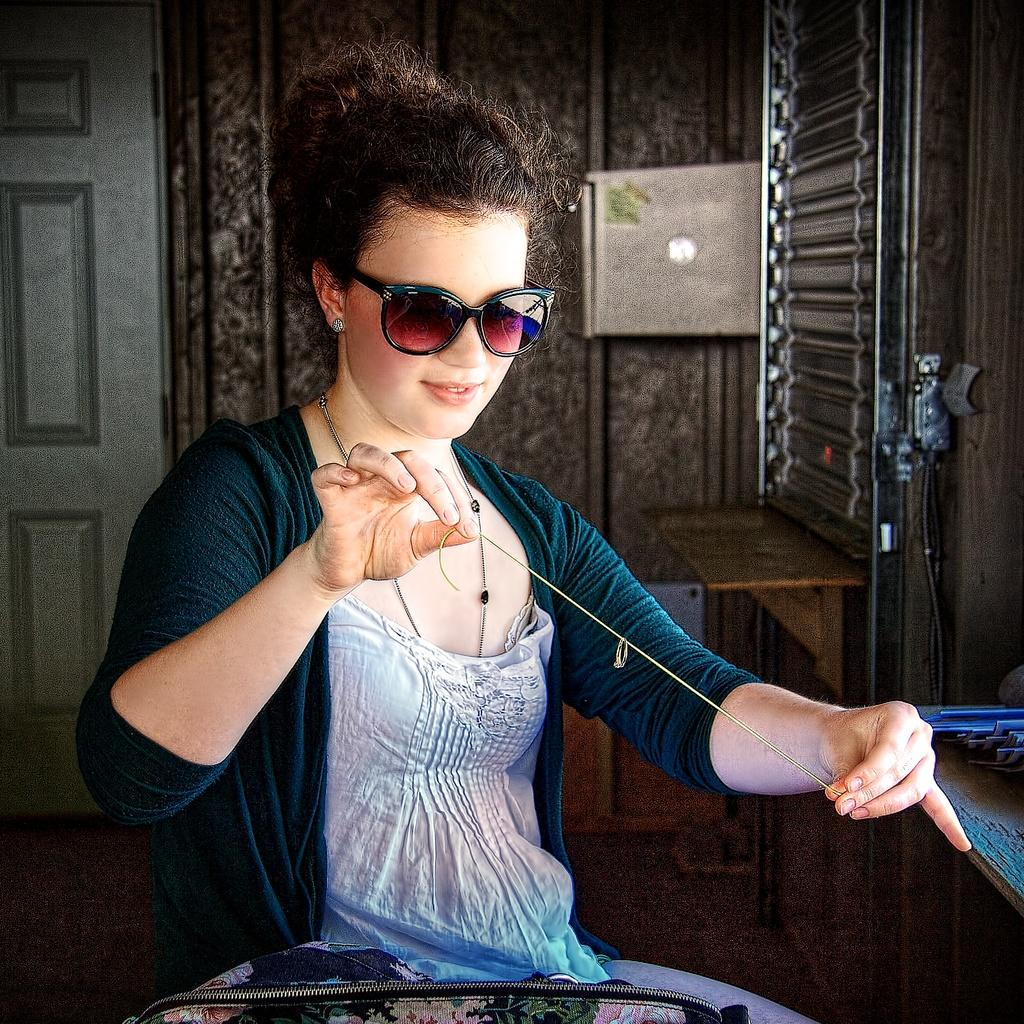What is the main subject of the image? There is a woman in the image. What is the woman doing with her hands? The woman is holding thread with her hands. What protective gear is the woman wearing? The woman is wearing goggles. What type of surface is visible in the image? There is a floor in the image. What architectural features can be seen in the background? There is a door and a wall in the background of the image. How many sheep are visible in the image? There are no sheep present in the image. What page is the woman turning in the image? There is no page or book present in the image, so it is not possible to determine if the woman is turning a page. 